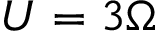Convert formula to latex. <formula><loc_0><loc_0><loc_500><loc_500>U = 3 \Omega</formula> 